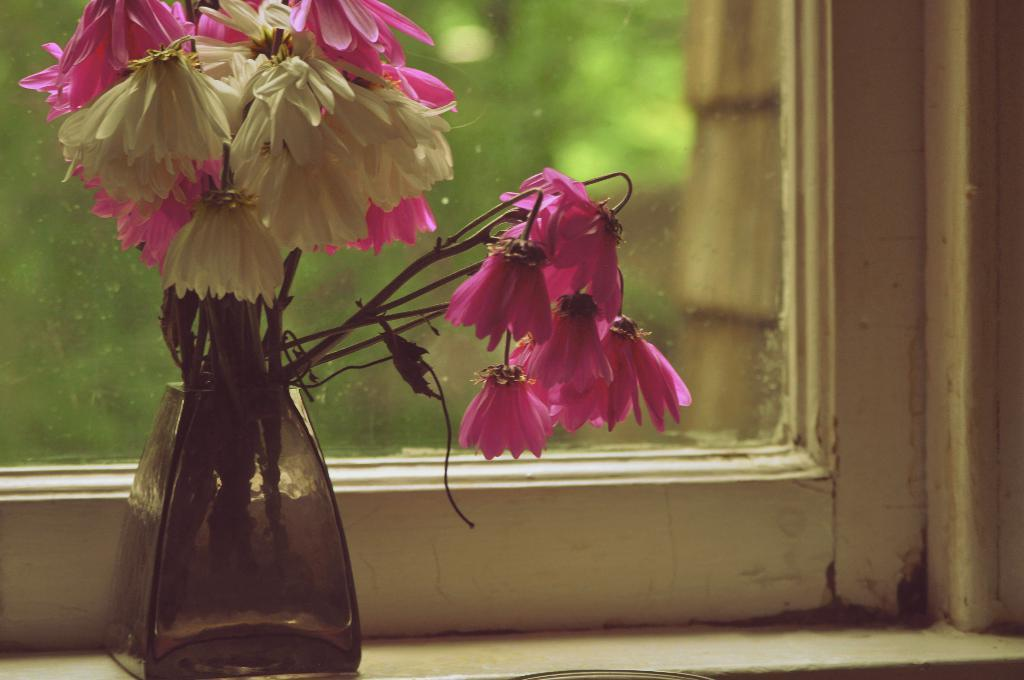What can be seen in the image that is used to hold flowers? There is a flower vase in the image. What colors are the flowers in the vase? The flowers are in pink and white colors. What is visible in the background of the image? There is a window visible in the background of the image. Where is the throne located in the image? There is no throne present in the image. What type of apples can be seen growing on the tree outside the window? There is no tree or apples visible in the image; only a window is present in the background. 